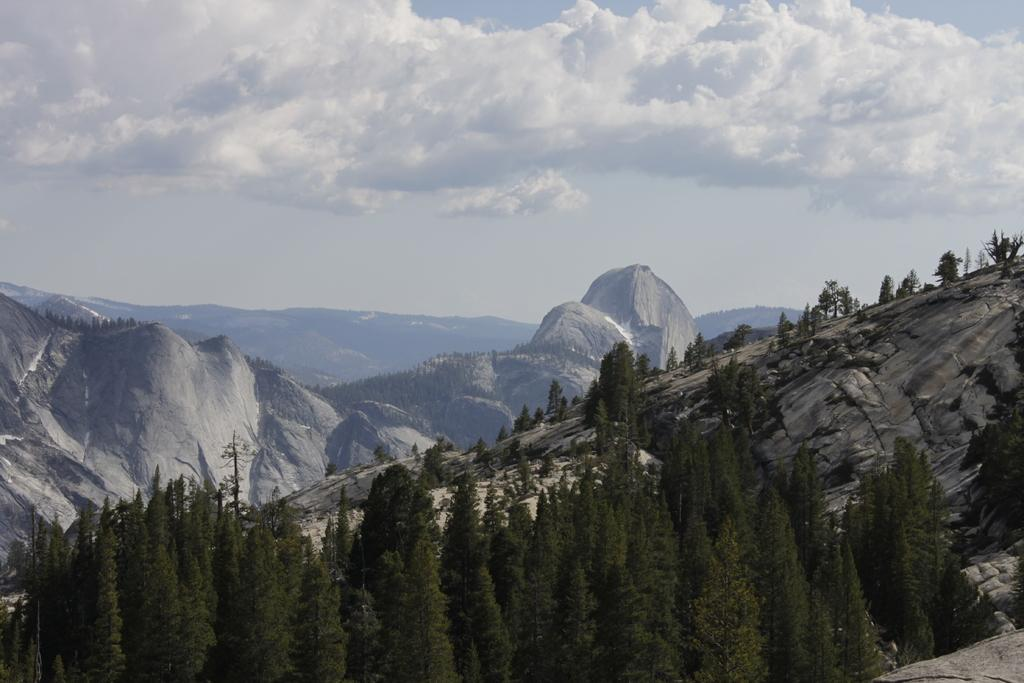What type of natural landscape is depicted in the image? The image features mountains and trees. What is the condition of the sky in the image? The sky is cloudy in the image. What societal limits are being imposed on the trees in the image? There is no indication of societal limits being imposed on the trees in the image; it simply depicts a natural landscape with mountains, trees, and a cloudy sky. 